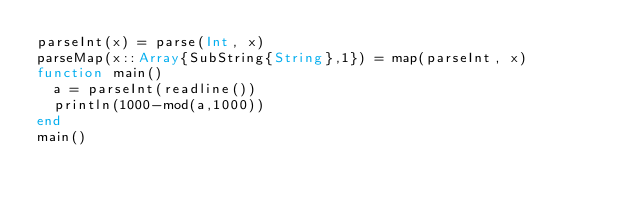Convert code to text. <code><loc_0><loc_0><loc_500><loc_500><_Julia_>parseInt(x) = parse(Int, x)
parseMap(x::Array{SubString{String},1}) = map(parseInt, x)
function main()
  a = parseInt(readline())
  println(1000-mod(a,1000))
end
main()  </code> 